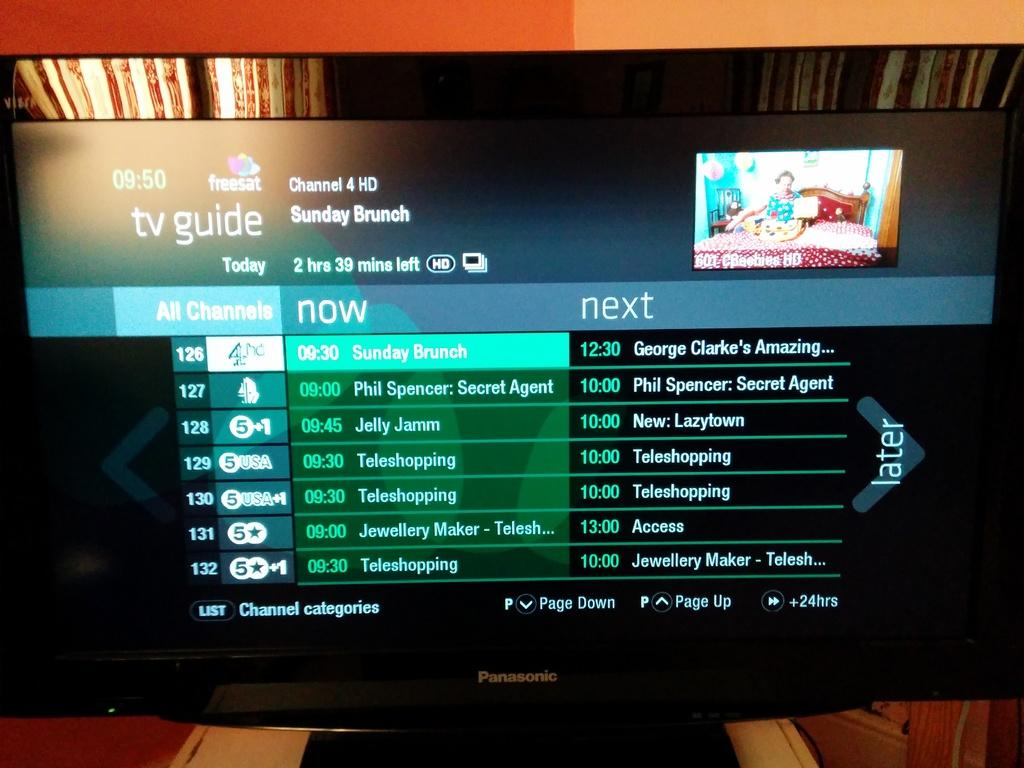<image>
Summarize the visual content of the image. A Panasonic television with the tv guide up on its display. 